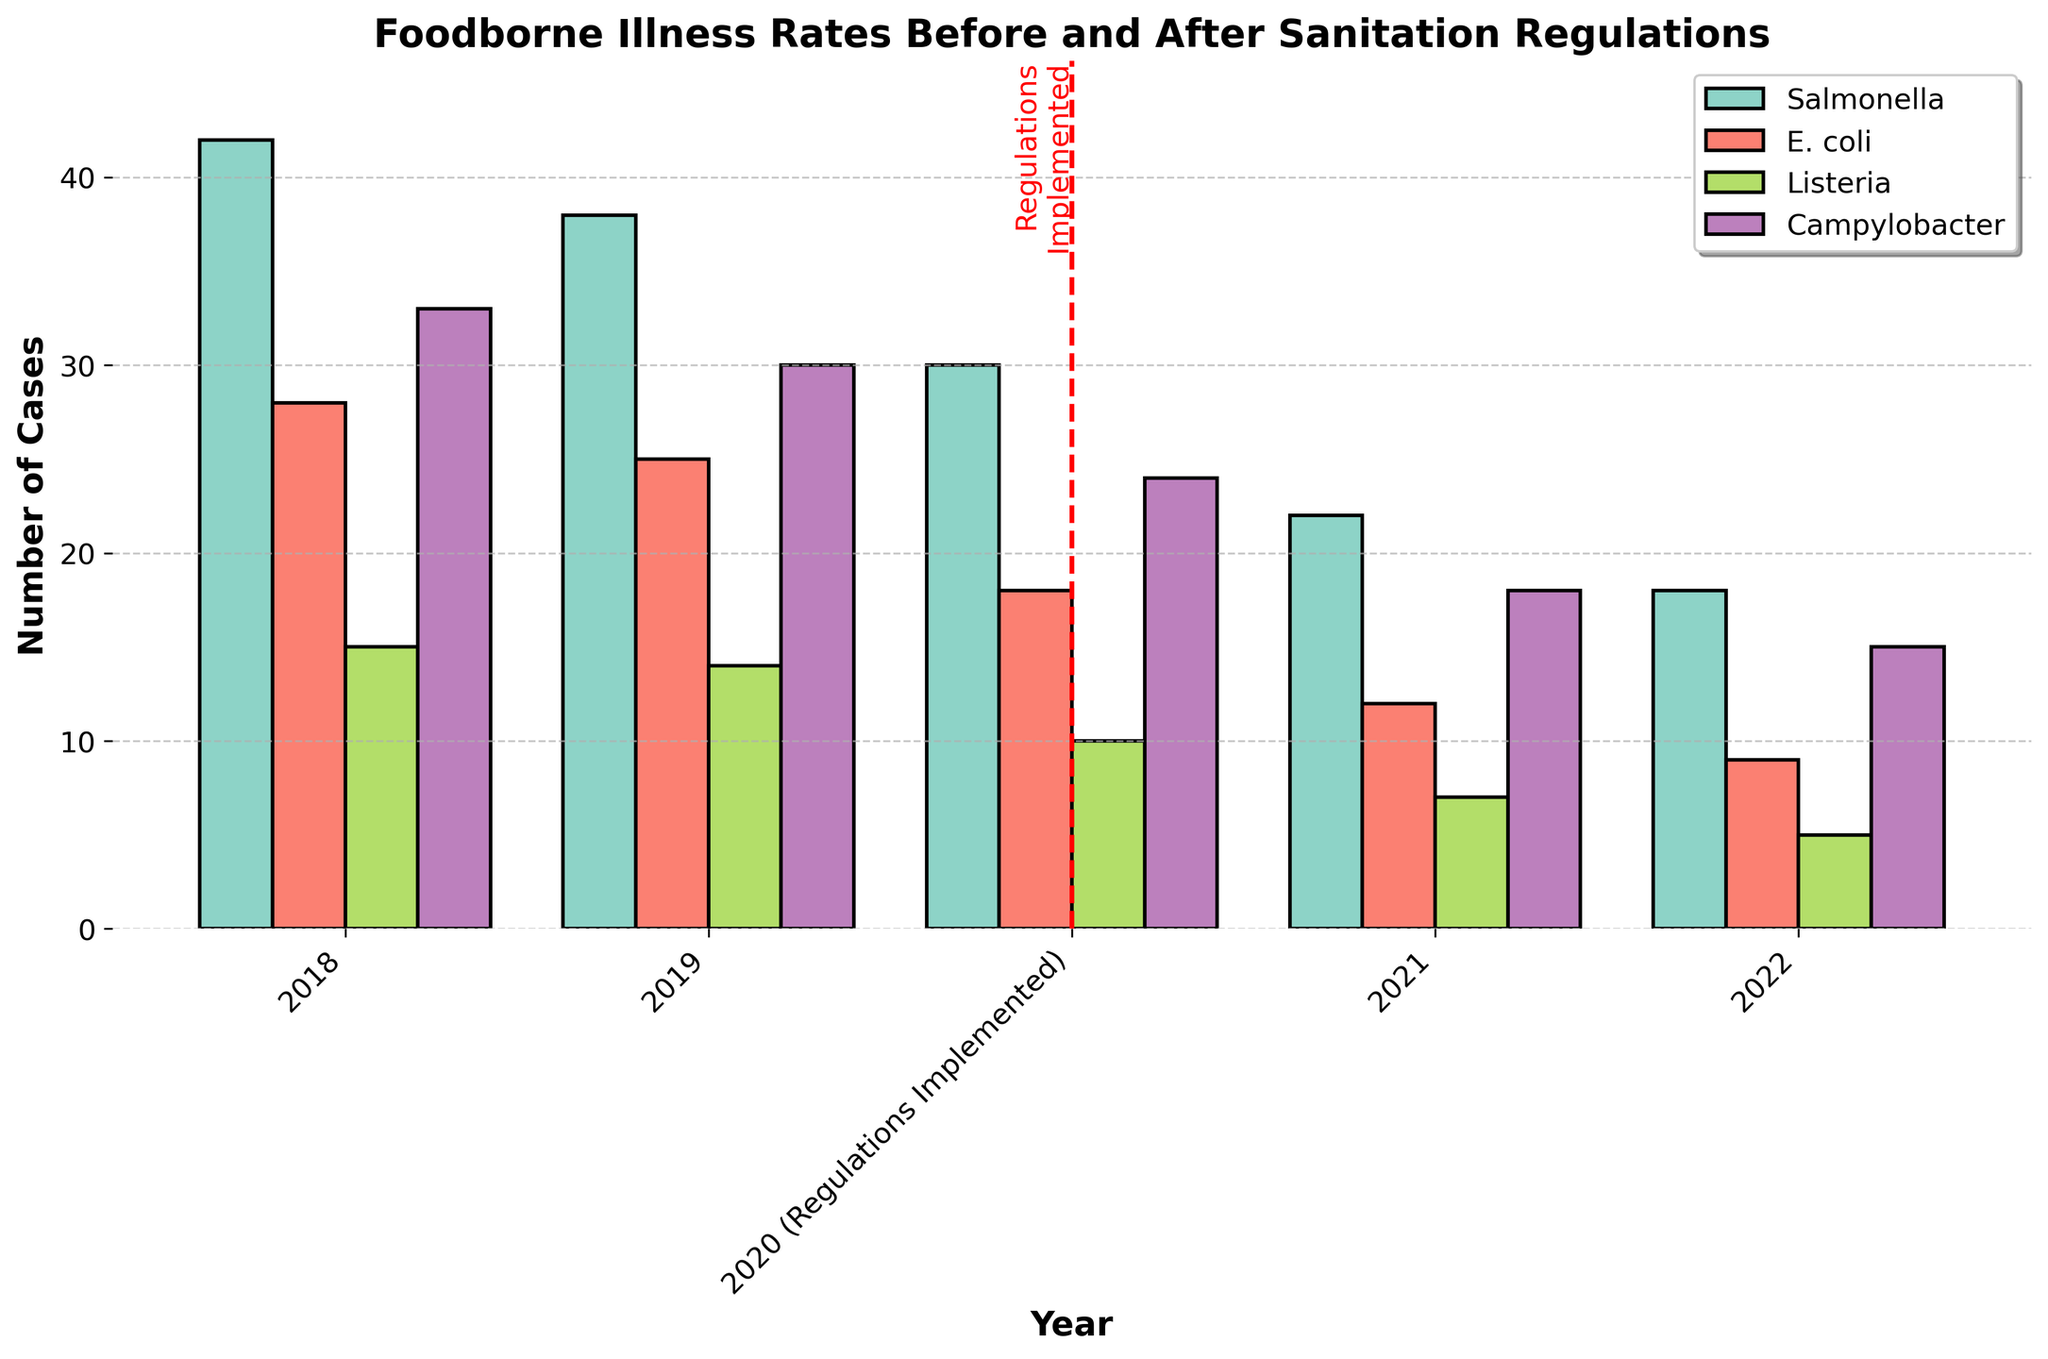What year shows the highest number of Salmonella cases? Look at the heights of the bars representing Salmonella in each year. The tallest bar is in 2018, corresponding to the highest number of cases.
Answer: 2018 By how much did the number of E. coli cases decrease from 2018 to 2020? In 2018, there are 28 cases of E. coli. In 2020, this number is 18. Subtract 18 from 28 to find the decrease: 28 - 18 = 10.
Answer: 10 Which illness had the smallest decrease in cases from 2018 to 2022? Calculate the decrease for each illness by subtracting the 2022 values from the 2018 values. The results are: Salmonella (42 - 18 = 24), E. coli (28 - 9 = 19), Listeria (15 - 5 = 10), Campylobacter (33 - 15 = 18). Listeria had the smallest decrease of 10.
Answer: Listeria In 2021, which foodborne illness had a lower number of cases than the rest? Compare the heights of all bars for 2021. The one with the lowest height represents the lowest number of cases. Listeria has the lowest number with 7 cases.
Answer: Listeria What is the trend of Campylobacter cases from 2018 to 2022? Observe the bars representing Campylobacter cases from 2018 to 2022. The number of cases consistently decreases each year.
Answer: Decreasing How many total cases of Salmonella are there from 2018 to 2022? Add the Salmonella cases for each year: 42 (2018) + 38 (2019) + 30 (2020) + 22 (2021) + 18 (2022). The total is 150.
Answer: 150 Did the implementation of sanitation regulations have an immediate impact on the number of foodborne illness cases in 2020? Compare the bar heights of 2020 with 2019. For all illnesses, the 2020 bars are shorter than 2019, indicating a decrease in cases immediately after the regulations were implemented.
Answer: Yes Which illness saw the largest percentage decrease in cases from 2018 to 2021? Calculate the percentage decrease for each illness from 2018 to 2021. The formulas are: Salmonella ((42-22)/42)*100 ≈ 47.6%, E. coli ((28-12)/28)*100 ≈ 57.1%, Listeria ((15-7)/15)*100 ≈ 53.3%, Campylobacter ((33-18)/33)*100 ≈ 45.5%. E. coli saw the largest percentage decrease.
Answer: E. coli 